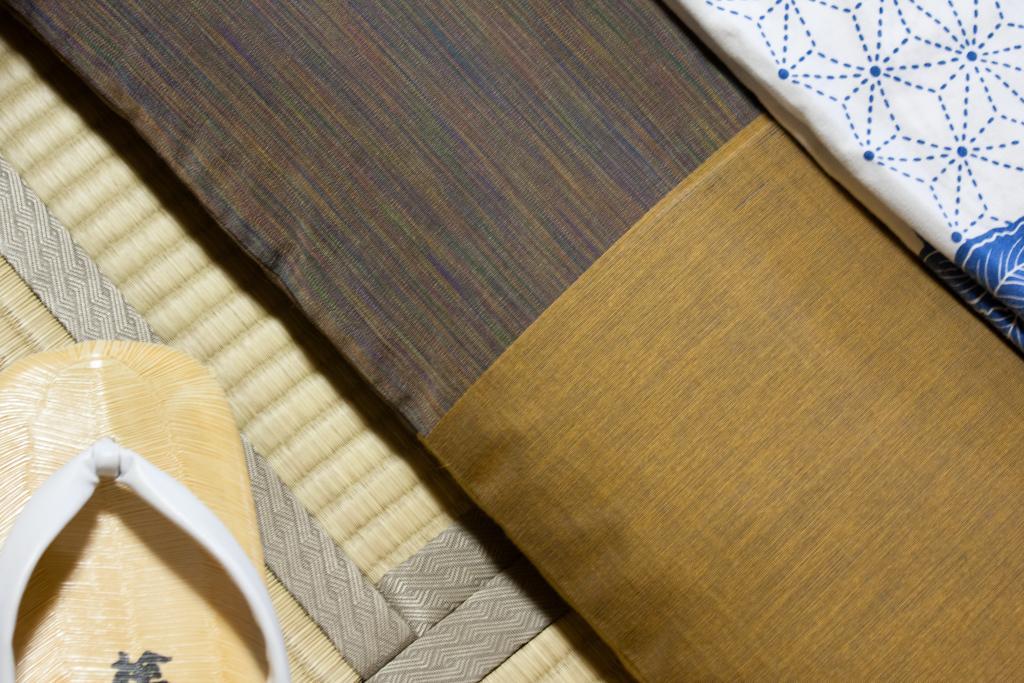Could you give a brief overview of what you see in this image? This image is taken indoors. At the bottom of the image there is a floor mat and there is a footwear on the floor mat. On the right side of the image there is a bed with a mattress and a bed sheet on it. 